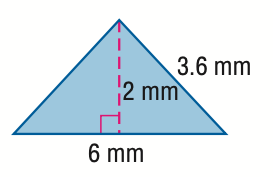Answer the mathemtical geometry problem and directly provide the correct option letter.
Question: Find the perimeter of the triangle. Round to the nearest tenth if necessary.
Choices: A: 6 B: 9.6 C: 12 D: 13.2 D 